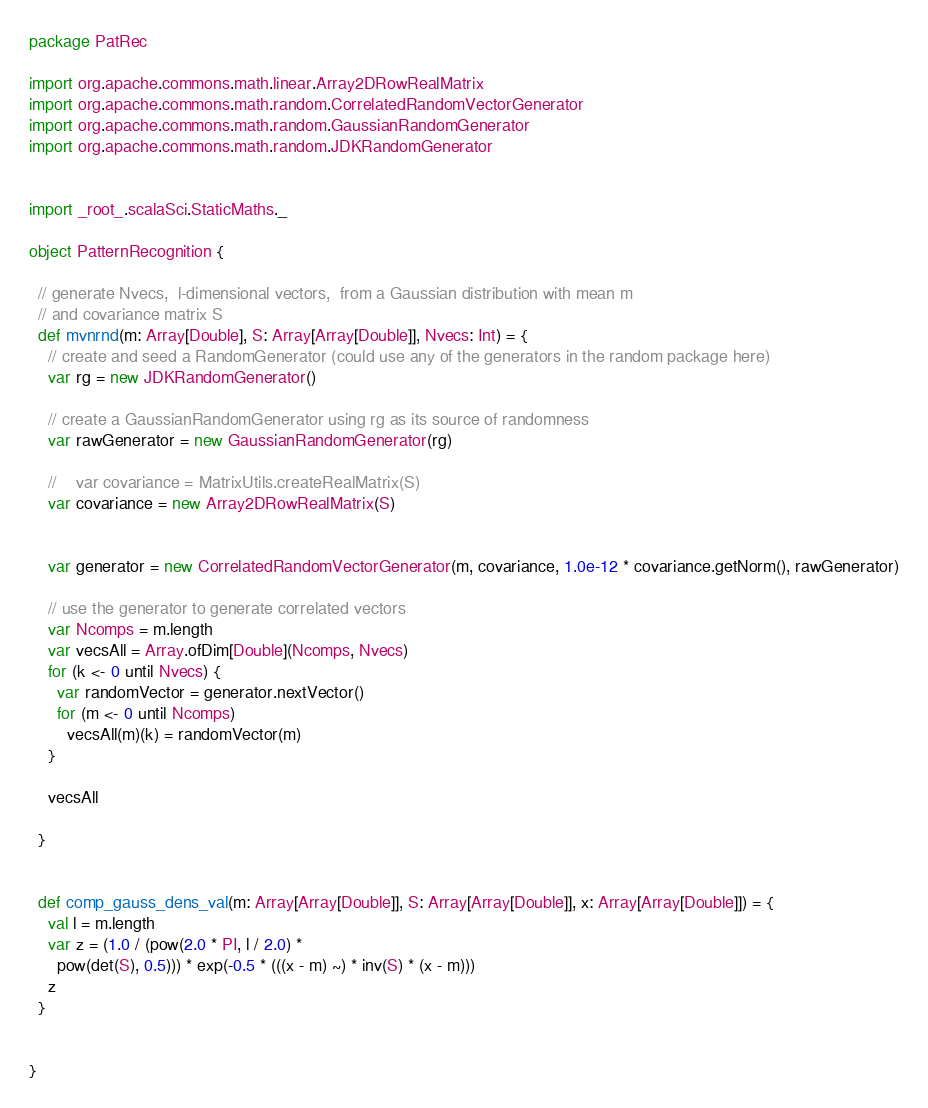Convert code to text. <code><loc_0><loc_0><loc_500><loc_500><_Scala_>package PatRec

import org.apache.commons.math.linear.Array2DRowRealMatrix
import org.apache.commons.math.random.CorrelatedRandomVectorGenerator
import org.apache.commons.math.random.GaussianRandomGenerator
import org.apache.commons.math.random.JDKRandomGenerator


import _root_.scalaSci.StaticMaths._

object PatternRecognition {

  // generate Nvecs,  l-dimensional vectors,  from a Gaussian distribution with mean m 
  // and covariance matrix S
  def mvnrnd(m: Array[Double], S: Array[Array[Double]], Nvecs: Int) = {
    // create and seed a RandomGenerator (could use any of the generators in the random package here)
    var rg = new JDKRandomGenerator()

    // create a GaussianRandomGenerator using rg as its source of randomness
    var rawGenerator = new GaussianRandomGenerator(rg)

    //    var covariance = MatrixUtils.createRealMatrix(S)
    var covariance = new Array2DRowRealMatrix(S)


    var generator = new CorrelatedRandomVectorGenerator(m, covariance, 1.0e-12 * covariance.getNorm(), rawGenerator)

    // use the generator to generate correlated vectors
    var Ncomps = m.length
    var vecsAll = Array.ofDim[Double](Ncomps, Nvecs)
    for (k <- 0 until Nvecs) {
      var randomVector = generator.nextVector()
      for (m <- 0 until Ncomps)
        vecsAll(m)(k) = randomVector(m)
    }

    vecsAll

  }


  def comp_gauss_dens_val(m: Array[Array[Double]], S: Array[Array[Double]], x: Array[Array[Double]]) = {
    val l = m.length
    var z = (1.0 / (pow(2.0 * PI, l / 2.0) *
      pow(det(S), 0.5))) * exp(-0.5 * (((x - m) ~) * inv(S) * (x - m)))
    z
  }


}
</code> 